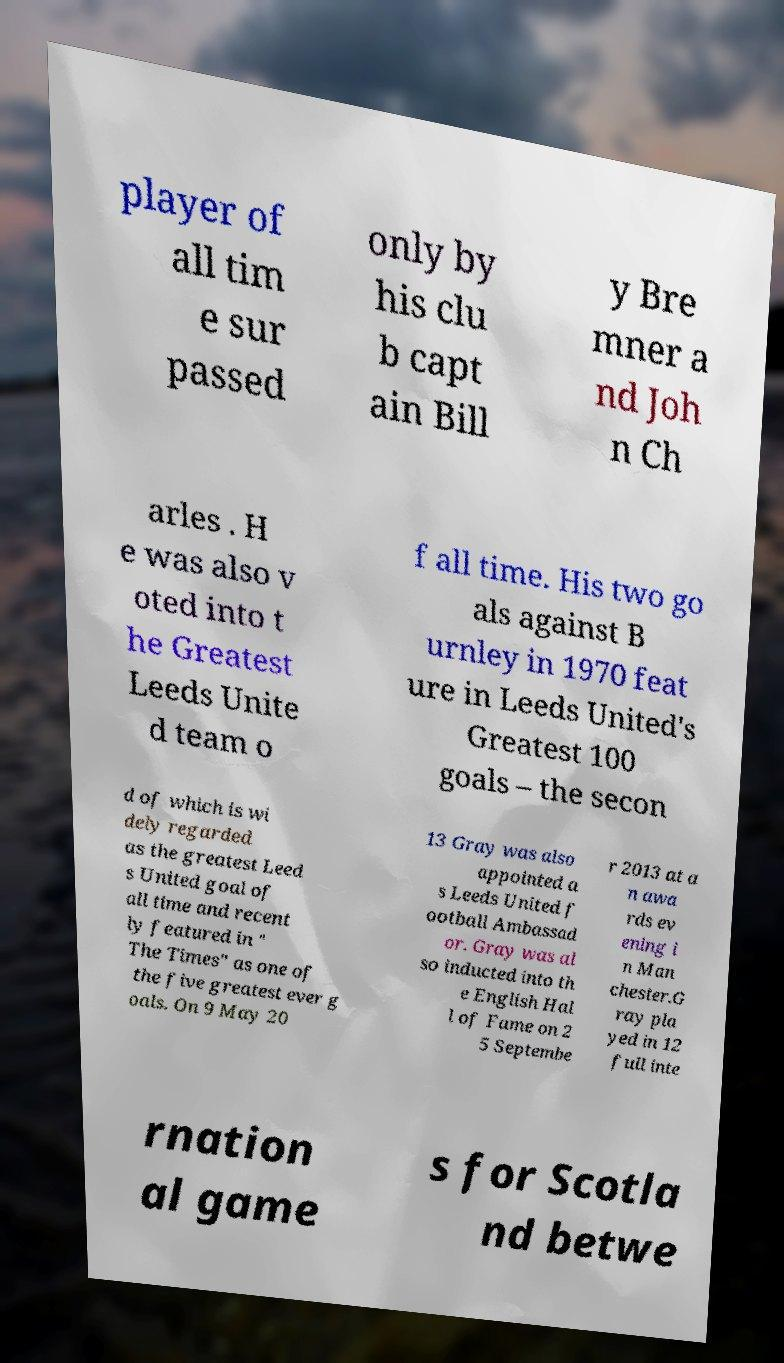Can you read and provide the text displayed in the image?This photo seems to have some interesting text. Can you extract and type it out for me? player of all tim e sur passed only by his clu b capt ain Bill y Bre mner a nd Joh n Ch arles . H e was also v oted into t he Greatest Leeds Unite d team o f all time. His two go als against B urnley in 1970 feat ure in Leeds United's Greatest 100 goals – the secon d of which is wi dely regarded as the greatest Leed s United goal of all time and recent ly featured in " The Times" as one of the five greatest ever g oals. On 9 May 20 13 Gray was also appointed a s Leeds United f ootball Ambassad or. Gray was al so inducted into th e English Hal l of Fame on 2 5 Septembe r 2013 at a n awa rds ev ening i n Man chester.G ray pla yed in 12 full inte rnation al game s for Scotla nd betwe 